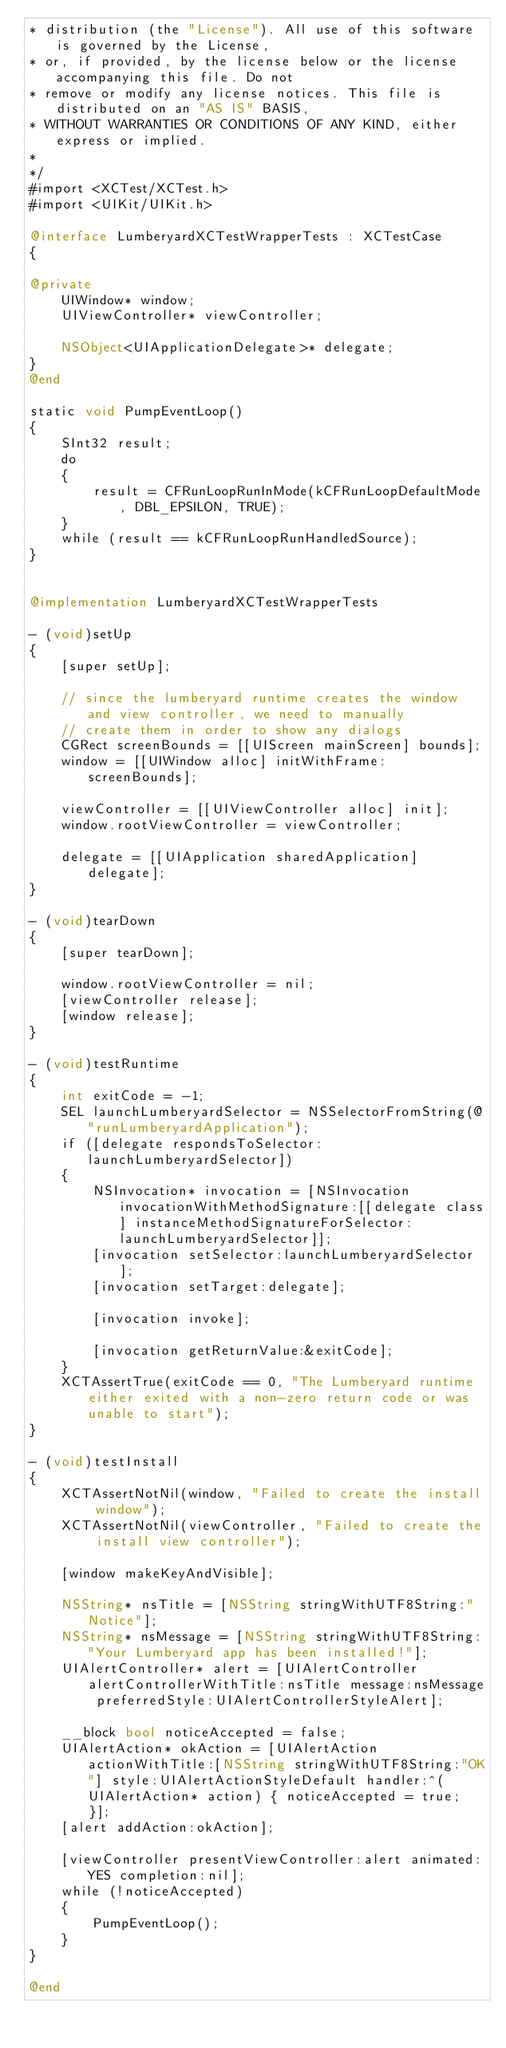Convert code to text. <code><loc_0><loc_0><loc_500><loc_500><_ObjectiveC_>* distribution (the "License"). All use of this software is governed by the License,
* or, if provided, by the license below or the license accompanying this file. Do not
* remove or modify any license notices. This file is distributed on an "AS IS" BASIS,
* WITHOUT WARRANTIES OR CONDITIONS OF ANY KIND, either express or implied.
*
*/
#import <XCTest/XCTest.h>
#import <UIKit/UIKit.h>

@interface LumberyardXCTestWrapperTests : XCTestCase
{

@private
    UIWindow* window;
    UIViewController* viewController;

    NSObject<UIApplicationDelegate>* delegate;
}
@end

static void PumpEventLoop()
{
    SInt32 result;
    do
    {
        result = CFRunLoopRunInMode(kCFRunLoopDefaultMode, DBL_EPSILON, TRUE);
    }
    while (result == kCFRunLoopRunHandledSource);
}


@implementation LumberyardXCTestWrapperTests

- (void)setUp
{
    [super setUp];

    // since the lumberyard runtime creates the window and view controller, we need to manually
    // create them in order to show any dialogs
    CGRect screenBounds = [[UIScreen mainScreen] bounds];
    window = [[UIWindow alloc] initWithFrame: screenBounds];

    viewController = [[UIViewController alloc] init];
    window.rootViewController = viewController;

    delegate = [[UIApplication sharedApplication] delegate];
}

- (void)tearDown
{
    [super tearDown];

    window.rootViewController = nil;
    [viewController release];
    [window release];
}

- (void)testRuntime
{
    int exitCode = -1;
    SEL launchLumberyardSelector = NSSelectorFromString(@"runLumberyardApplication");
    if ([delegate respondsToSelector:launchLumberyardSelector])
    {
        NSInvocation* invocation = [NSInvocation invocationWithMethodSignature:[[delegate class] instanceMethodSignatureForSelector:launchLumberyardSelector]];
        [invocation setSelector:launchLumberyardSelector];
        [invocation setTarget:delegate];

        [invocation invoke];

        [invocation getReturnValue:&exitCode];
    }
    XCTAssertTrue(exitCode == 0, "The Lumberyard runtime either exited with a non-zero return code or was unable to start");
}

- (void)testInstall
{
    XCTAssertNotNil(window, "Failed to create the install window");
    XCTAssertNotNil(viewController, "Failed to create the install view controller");

    [window makeKeyAndVisible];

    NSString* nsTitle = [NSString stringWithUTF8String:"Notice"];
    NSString* nsMessage = [NSString stringWithUTF8String:"Your Lumberyard app has been installed!"];
    UIAlertController* alert = [UIAlertController alertControllerWithTitle:nsTitle message:nsMessage preferredStyle:UIAlertControllerStyleAlert];

    __block bool noticeAccepted = false;
    UIAlertAction* okAction = [UIAlertAction actionWithTitle:[NSString stringWithUTF8String:"OK"] style:UIAlertActionStyleDefault handler:^(UIAlertAction* action) { noticeAccepted = true; }];
    [alert addAction:okAction];

    [viewController presentViewController:alert animated:YES completion:nil];
    while (!noticeAccepted)
    {
        PumpEventLoop();
    }
}

@end
</code> 